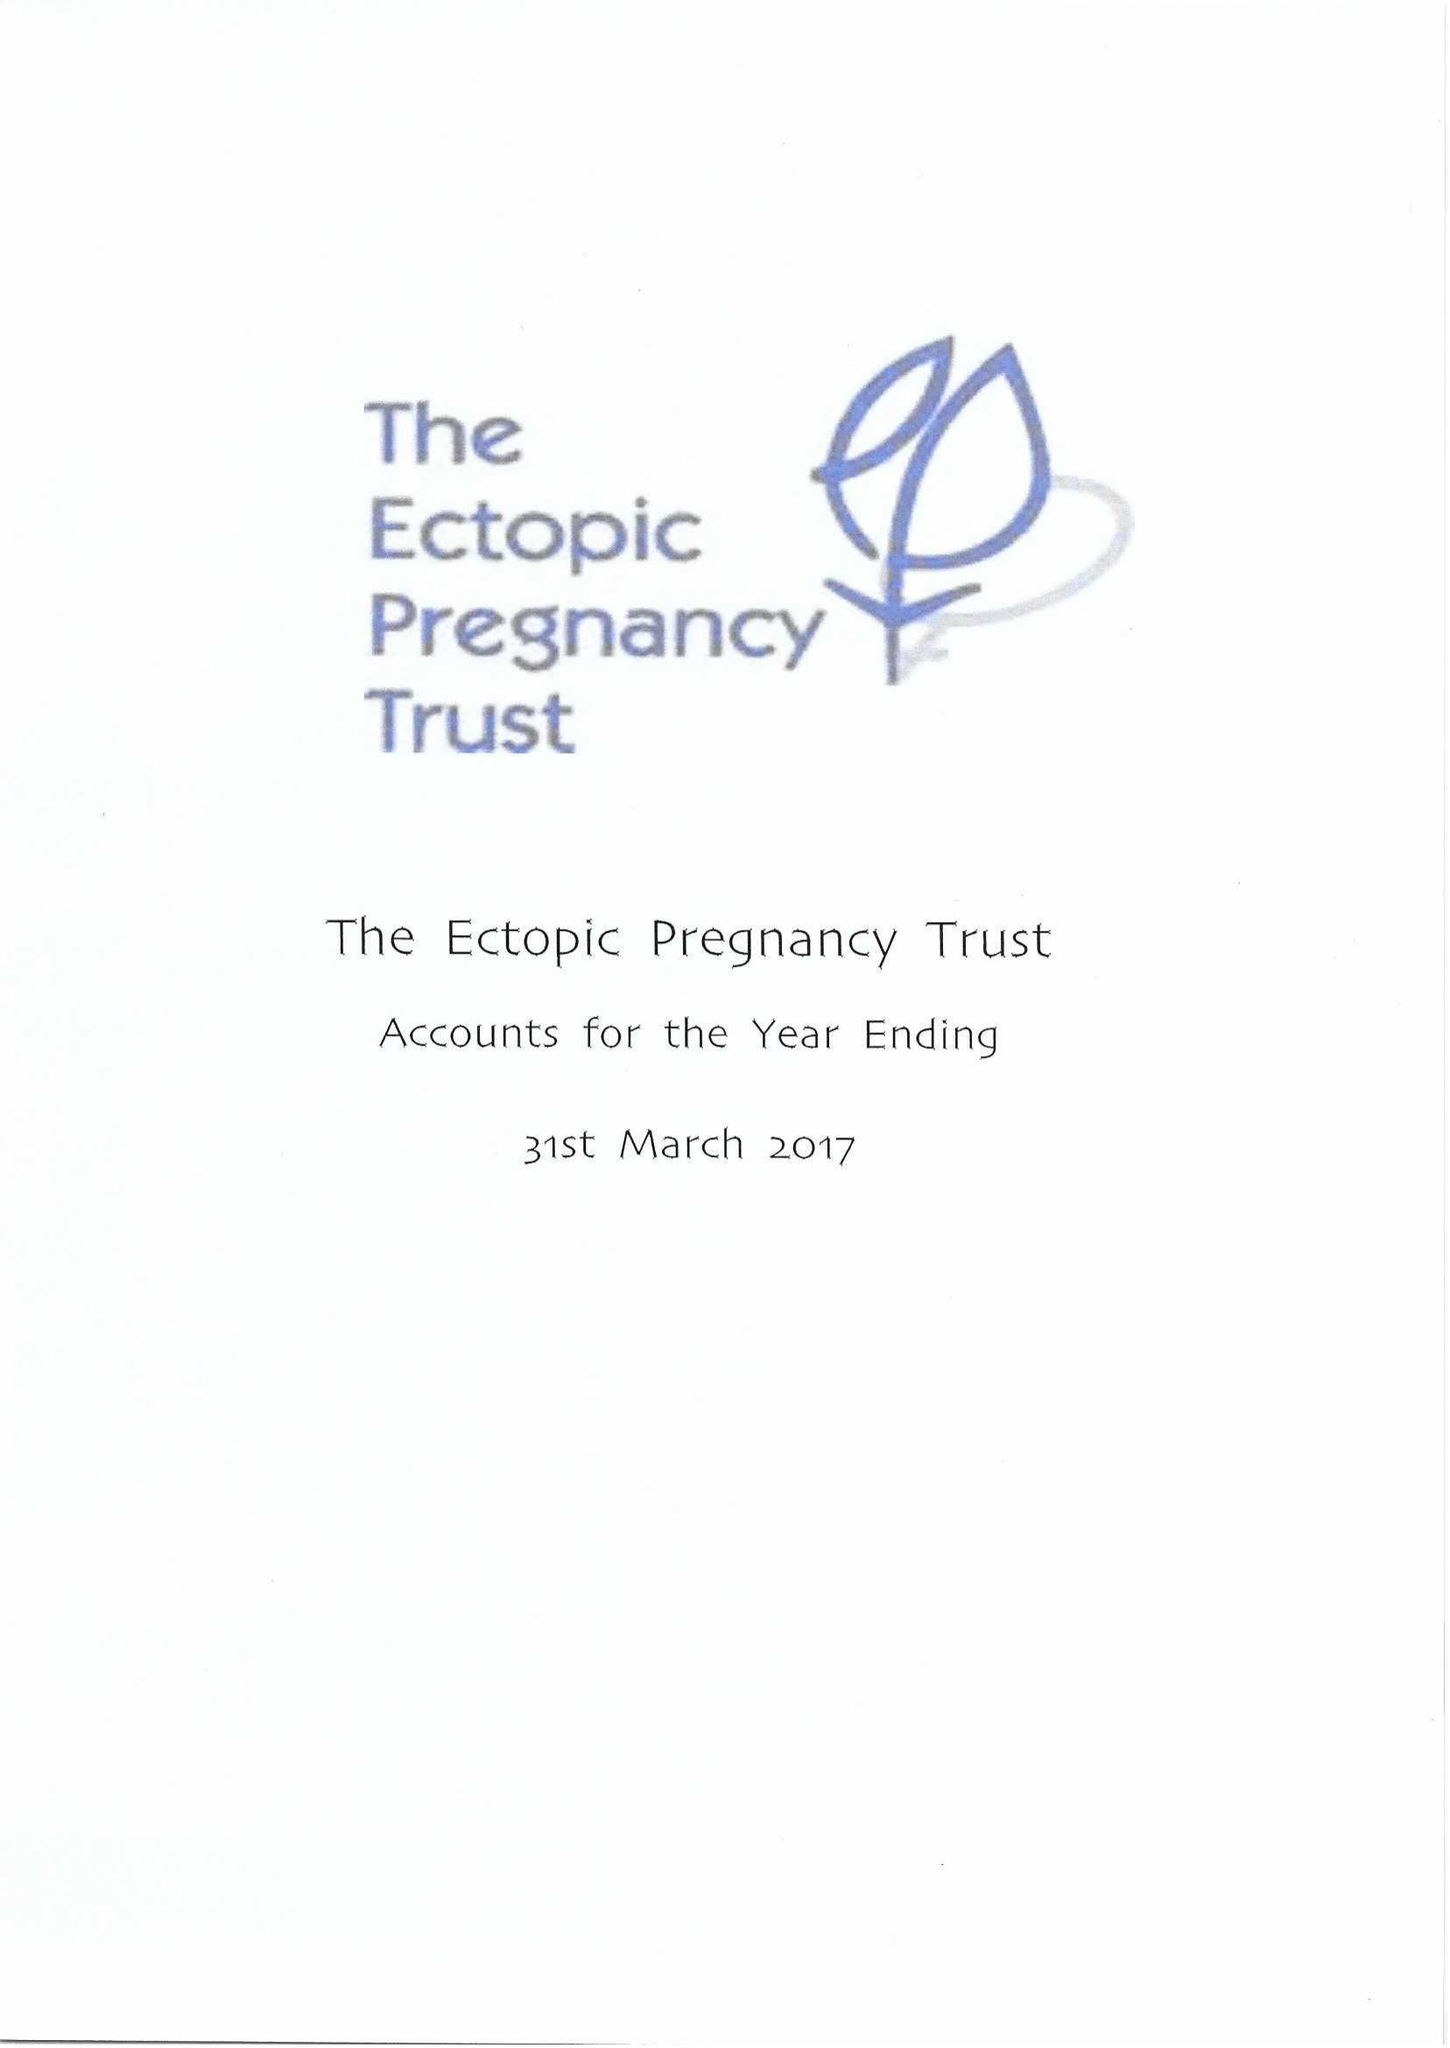What is the value for the address__postcode?
Answer the question using a single word or phrase. N13 4BS 